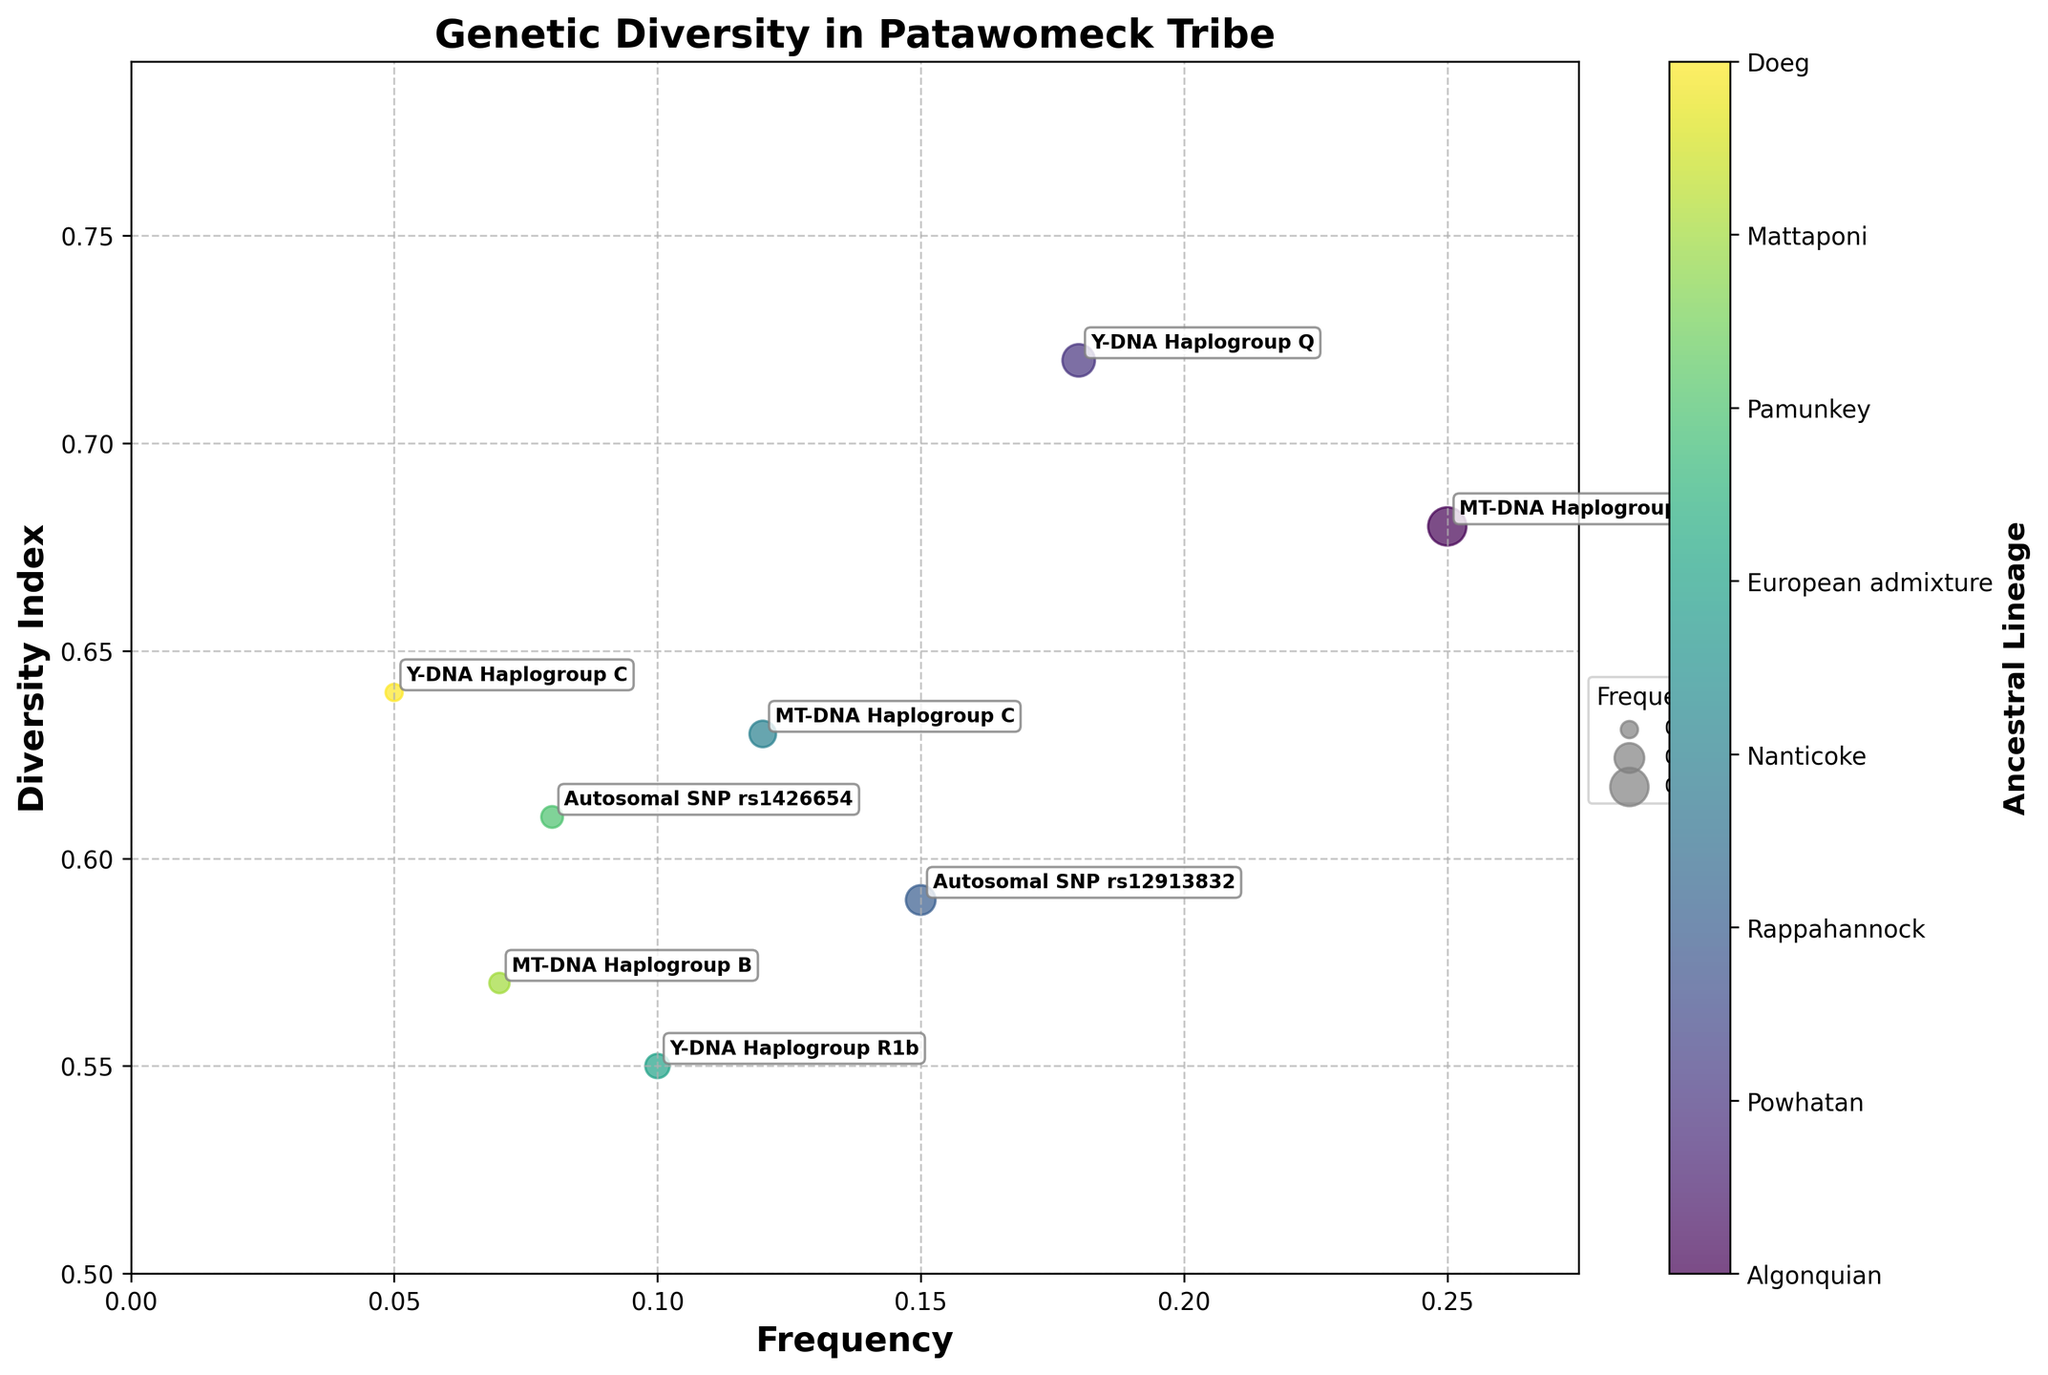What is the title of the figure? The title of the figure is located at the top of the plot and is clearly shown in larger, bold text.
Answer: Genetic Diversity in Patawomeck Tribe What are the two axes labels in the plot? The x-axis label is typically located below the horizontal axis, and the y-axis label is next to the vertical axis.
Answer: Frequency, Diversity Index Which genetic marker has the highest frequency? By looking at the x-axis position of the points, we can determine the genetic marker placed furthest to the right.
Answer: MT-DNA Haplogroup A How many data points are included in the figure? Each data point represents a combination of frequency and diversity index and is denoted by a scatter plot marker. By counting the points on the plot, we find the total number of data points.
Answer: 8 What is the frequency of the Nanticoke lineage? Locate the MT-DNA Haplogroup C marker and refer to its position on the x-axis to determine its frequency.
Answer: 0.12 Which genetic marker has the lowest diversity index? By examining the points' positions on the y-axis, we can identify the point closest to the bottom of the plot.
Answer: Y-DNA Haplogroup R1b Which two genetic markers have a similar diversity index of around 0.63? We look at the y-axis and find the markers positioned at approximately the same y-value of 0.63.
Answer: MT-DNA Haplogroup C and Y-DNA Haplogroup C What is the difference in frequency between MT-DNA Haplogroup A and Y-DNA Haplogroup Q? Find the frequencies of both markers from the x-axis (0.25 for MT-DNA Haplogroup A and 0.18 for Y-DNA Haplogroup Q) and subtract the smaller from the larger. 0.25 - 0.18 = 0.07
Answer: 0.07 Which genetic marker represents the Pamunkey lineage, and what is its respective diversity index? Locate the marker labeled as Autosomal SNP rs1426654, and read its y-axis value for the diversity index.
Answer: Autosomal SNP rs1426654, 0.61 How does the diversity index of the Doeg lineage compare to that of the Mattaponi lineage? Identify and compare the y-axis positions of Y-DNA Haplogroup C (Doeg) and MT-DNA Haplogroup B (Mattaponi).
Answer: The Doeg lineage (0.64) has a slightly higher diversity index than the Mattaponi lineage (0.57) 